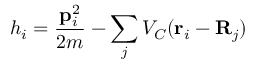Convert formula to latex. <formula><loc_0><loc_0><loc_500><loc_500>h _ { i } = \frac { { p } _ { i } ^ { 2 } } { 2 m } - \sum _ { j } V _ { C } ( { r } _ { i } - { R } _ { j } )</formula> 